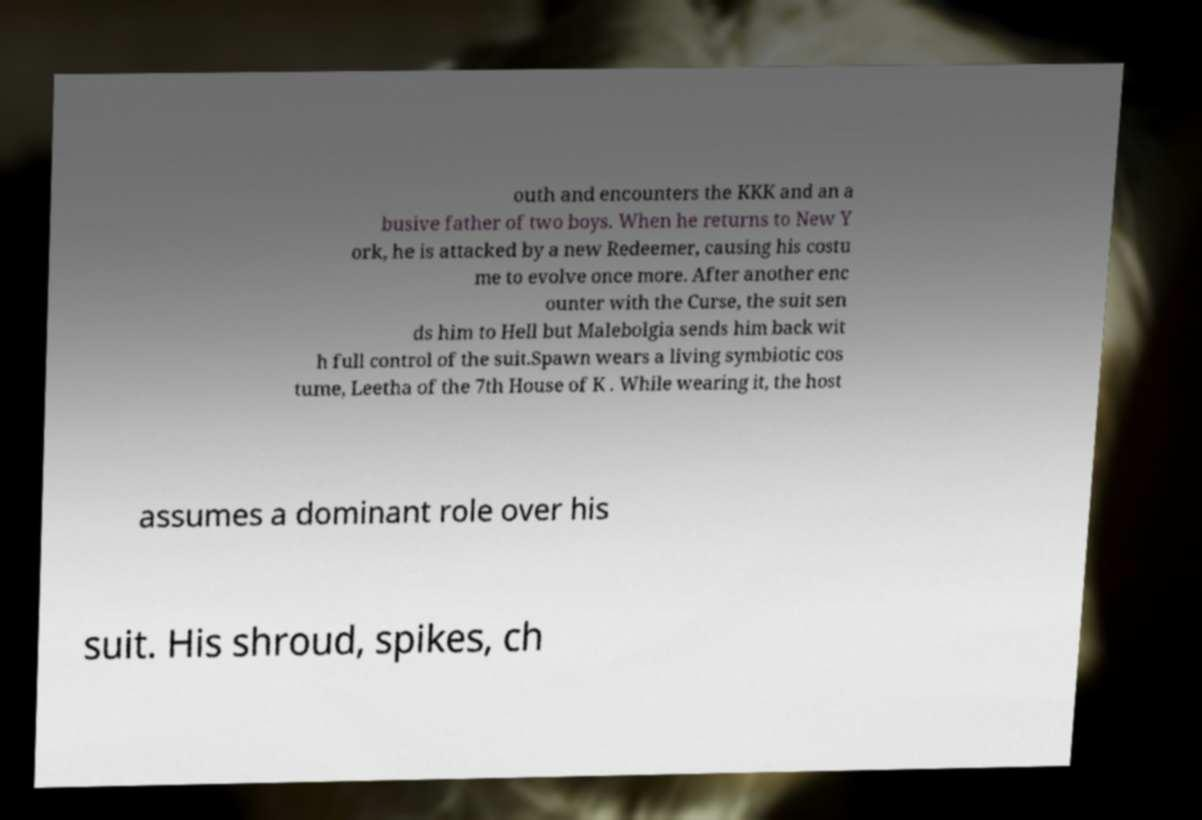Please identify and transcribe the text found in this image. outh and encounters the KKK and an a busive father of two boys. When he returns to New Y ork, he is attacked by a new Redeemer, causing his costu me to evolve once more. After another enc ounter with the Curse, the suit sen ds him to Hell but Malebolgia sends him back wit h full control of the suit.Spawn wears a living symbiotic cos tume, Leetha of the 7th House of K . While wearing it, the host assumes a dominant role over his suit. His shroud, spikes, ch 